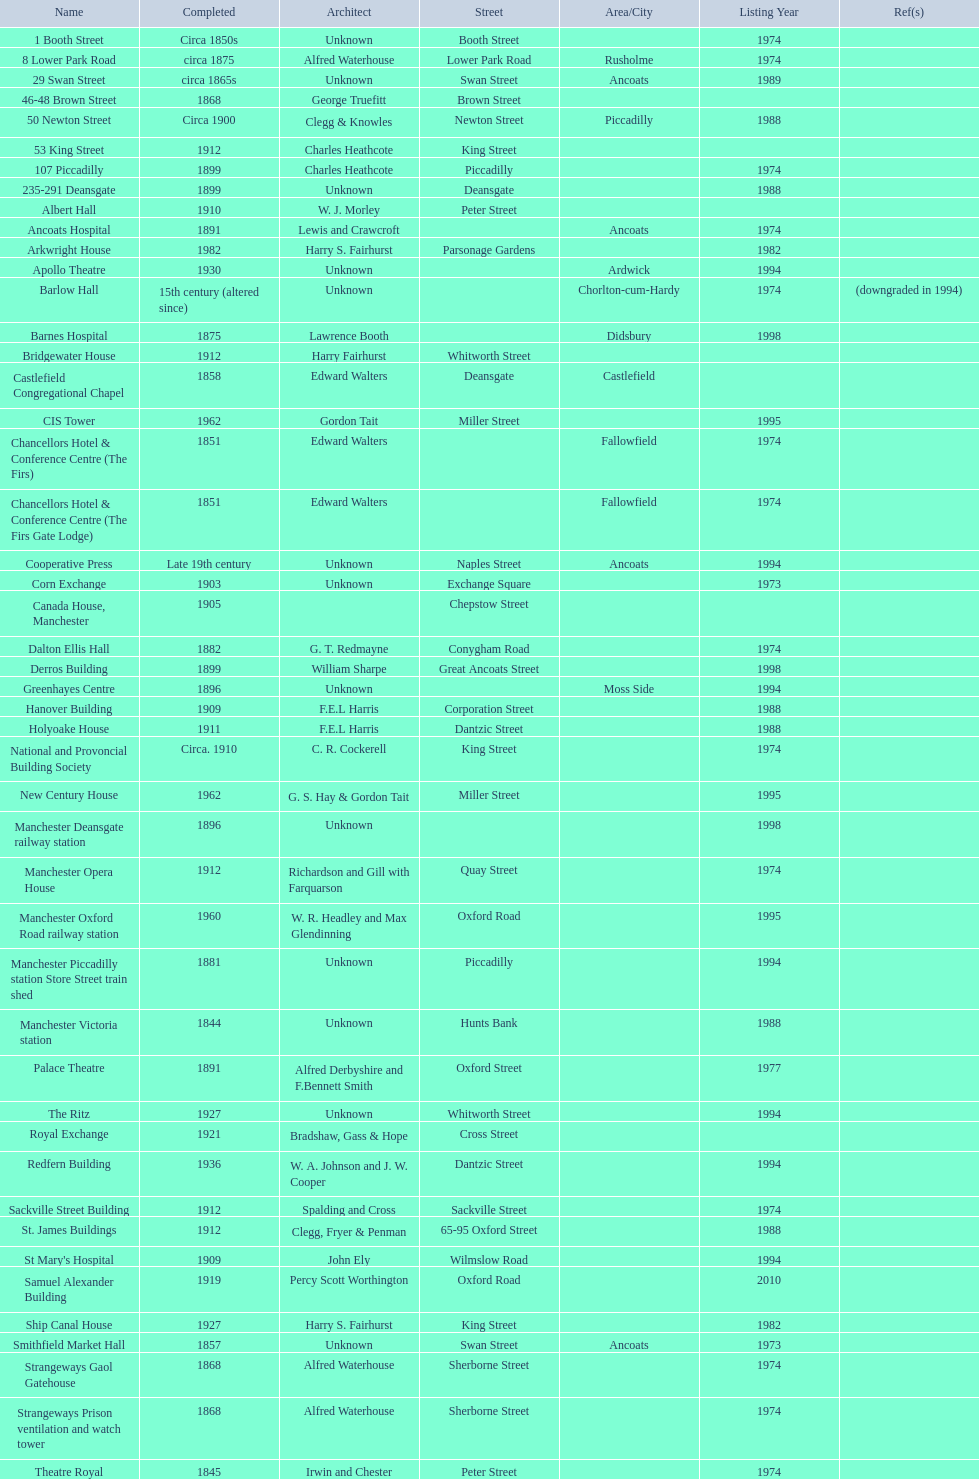What is the street of the only building listed in 1989? Swan Street. 